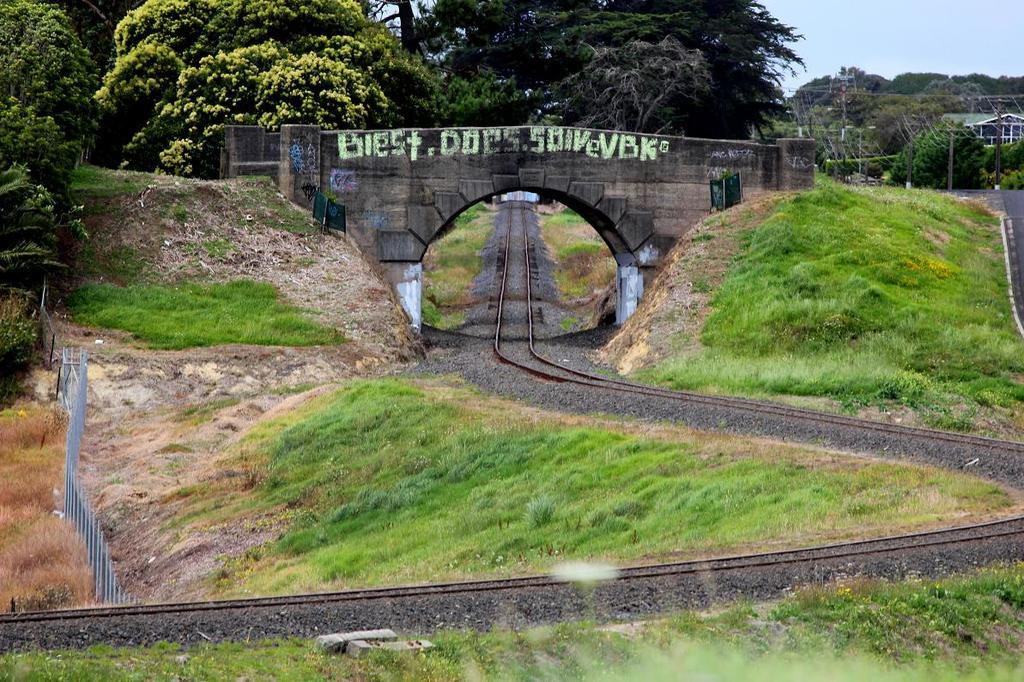Provide a one-sentence caption for the provided image. German graffiti on a stone bridge over a railroad tracks. 